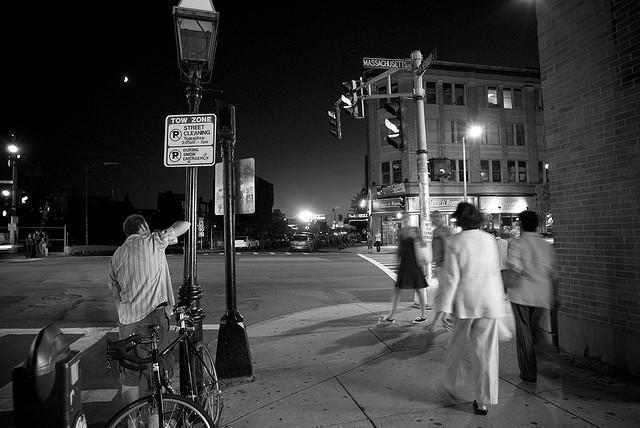What street name or intersection can be clearly seen on the corner?
Indicate the correct choice and explain in the format: 'Answer: answer
Rationale: rationale.'
Options: Tow, massachusetts, perry, roma. Answer: massachusetts.
Rationale: The name is on the sign on the pole 